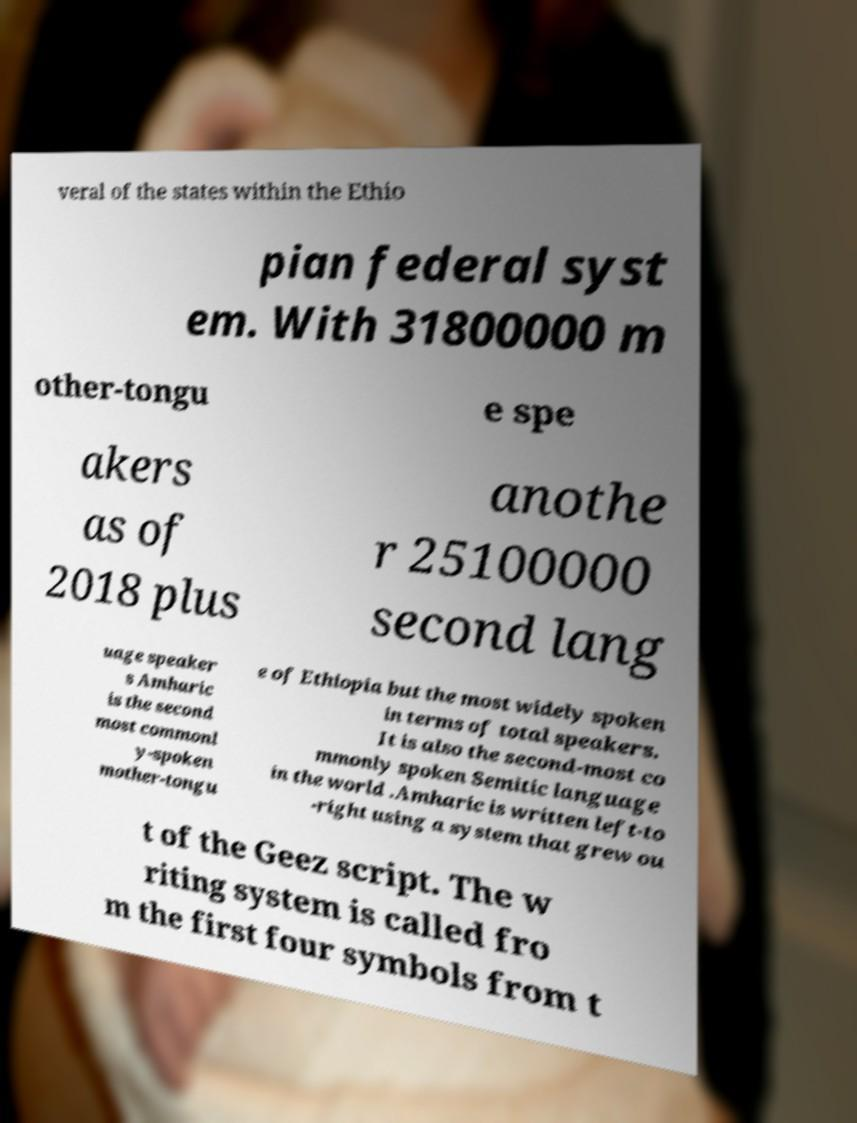There's text embedded in this image that I need extracted. Can you transcribe it verbatim? veral of the states within the Ethio pian federal syst em. With 31800000 m other-tongu e spe akers as of 2018 plus anothe r 25100000 second lang uage speaker s Amharic is the second most commonl y-spoken mother-tongu e of Ethiopia but the most widely spoken in terms of total speakers. It is also the second-most co mmonly spoken Semitic language in the world .Amharic is written left-to -right using a system that grew ou t of the Geez script. The w riting system is called fro m the first four symbols from t 